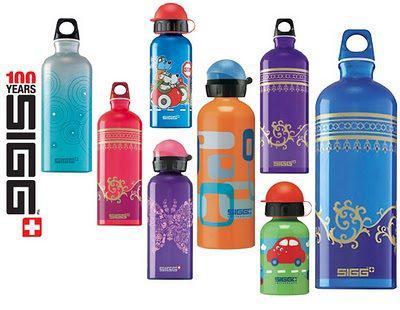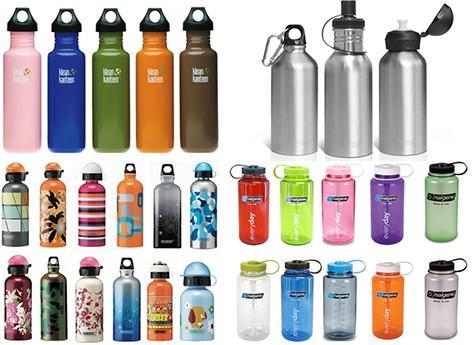The first image is the image on the left, the second image is the image on the right. Given the left and right images, does the statement "There are more bottles in the left image than the right." hold true? Answer yes or no. No. 